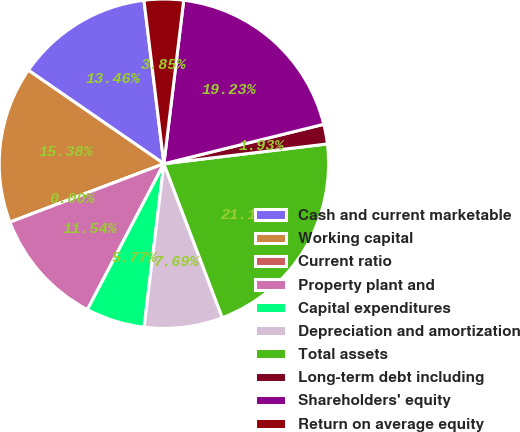<chart> <loc_0><loc_0><loc_500><loc_500><pie_chart><fcel>Cash and current marketable<fcel>Working capital<fcel>Current ratio<fcel>Property plant and<fcel>Capital expenditures<fcel>Depreciation and amortization<fcel>Total assets<fcel>Long-term debt including<fcel>Shareholders' equity<fcel>Return on average equity<nl><fcel>13.46%<fcel>15.38%<fcel>0.0%<fcel>11.54%<fcel>5.77%<fcel>7.69%<fcel>21.15%<fcel>1.93%<fcel>19.23%<fcel>3.85%<nl></chart> 